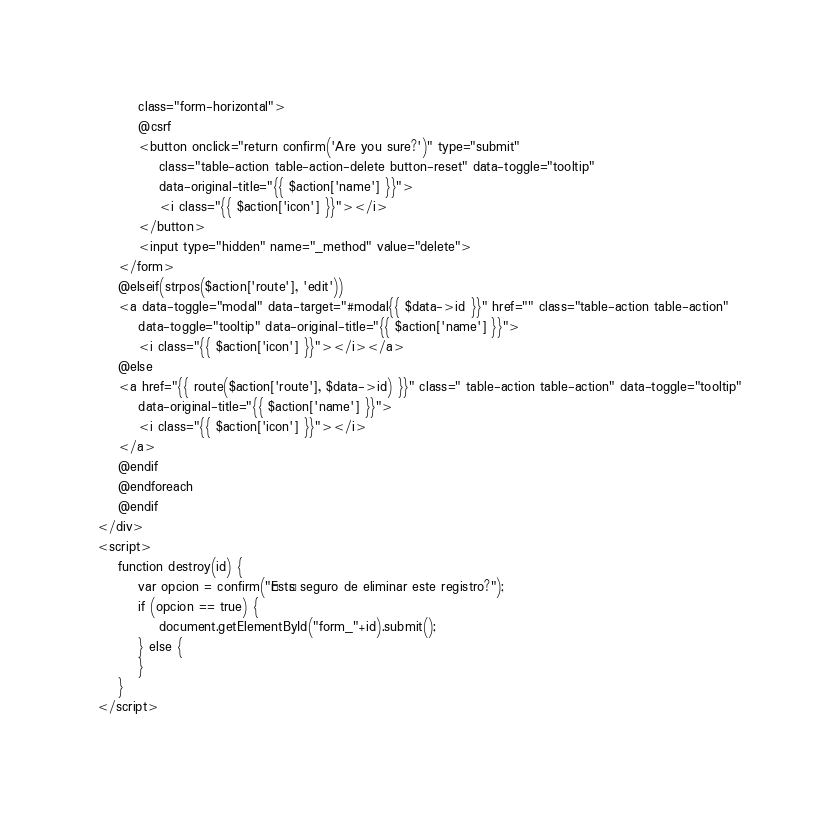Convert code to text. <code><loc_0><loc_0><loc_500><loc_500><_PHP_>        class="form-horizontal">
        @csrf
        <button onclick="return confirm('Are you sure?')" type="submit"
            class="table-action table-action-delete button-reset" data-toggle="tooltip"
            data-original-title="{{ $action['name'] }}">
            <i class="{{ $action['icon'] }}"></i>
        </button>
        <input type="hidden" name="_method" value="delete">
    </form>
    @elseif(strpos($action['route'], 'edit'))
    <a data-toggle="modal" data-target="#modal{{ $data->id }}" href="" class="table-action table-action"
        data-toggle="tooltip" data-original-title="{{ $action['name'] }}">
        <i class="{{ $action['icon'] }}"></i></a>
    @else
    <a href="{{ route($action['route'], $data->id) }}" class=" table-action table-action" data-toggle="tooltip"
        data-original-title="{{ $action['name'] }}">
        <i class="{{ $action['icon'] }}"></i>
    </a>
    @endif
    @endforeach
    @endif
</div>
<script>
    function destroy(id) {
        var opcion = confirm("¿Estás seguro de eliminar este registro?");
        if (opcion == true) {
            document.getElementById("form_"+id).submit();
        } else {
        }
    }
</script></code> 